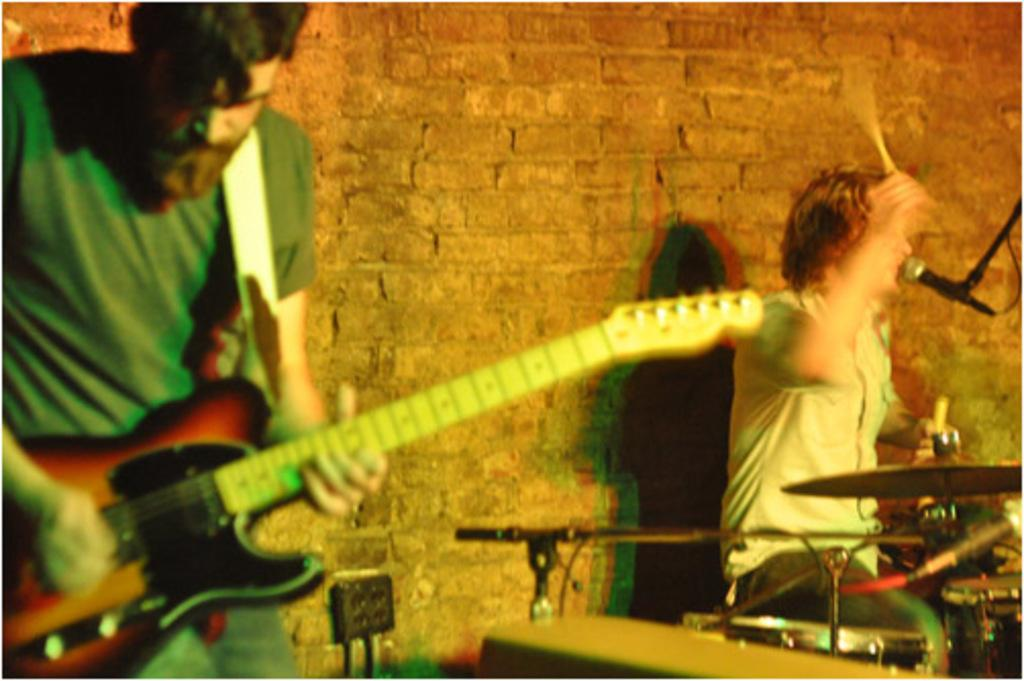How many people are in the image? There are two persons in the image. What are the two persons doing? One person is playing a guitar, and the other person is playing drums. What object is in front of one of the persons? There is a microphone in front of one of the persons. What can be seen in the background of the image? There is a brick wall in the background of the image. What type of nut is being cracked by the person playing the guitar in the image? There is no nut present in the image, and the person playing the guitar is not shown cracking a nut. 